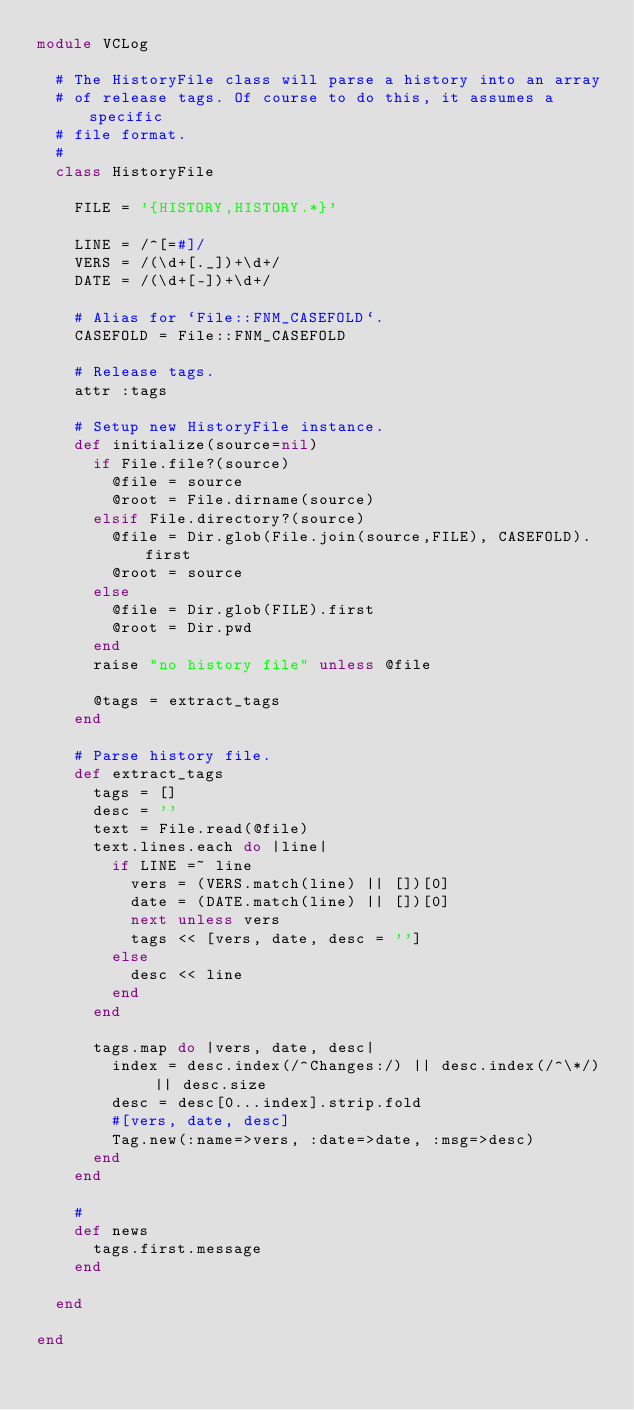Convert code to text. <code><loc_0><loc_0><loc_500><loc_500><_Ruby_>module VCLog

  # The HistoryFile class will parse a history into an array
  # of release tags. Of course to do this, it assumes a specific
  # file format.
  #
  class HistoryFile

    FILE = '{HISTORY,HISTORY.*}'

    LINE = /^[=#]/
    VERS = /(\d+[._])+\d+/
    DATE = /(\d+[-])+\d+/

    # Alias for `File::FNM_CASEFOLD`.
    CASEFOLD = File::FNM_CASEFOLD

    # Release tags.
    attr :tags

    # Setup new HistoryFile instance.
    def initialize(source=nil)
      if File.file?(source)
        @file = source
        @root = File.dirname(source)
      elsif File.directory?(source)
        @file = Dir.glob(File.join(source,FILE), CASEFOLD).first
        @root = source
      else
        @file = Dir.glob(FILE).first
        @root = Dir.pwd
      end
      raise "no history file" unless @file

      @tags = extract_tags
    end

    # Parse history file.
    def extract_tags
      tags = []
      desc = ''
      text = File.read(@file)
      text.lines.each do |line|
        if LINE =~ line
          vers = (VERS.match(line) || [])[0]
          date = (DATE.match(line) || [])[0]
          next unless vers
          tags << [vers, date, desc = '']
        else
          desc << line
        end
      end

      tags.map do |vers, date, desc|
        index = desc.index(/^Changes:/) || desc.index(/^\*/) || desc.size
        desc = desc[0...index].strip.fold
        #[vers, date, desc]
        Tag.new(:name=>vers, :date=>date, :msg=>desc)
      end
    end

    #
    def news
      tags.first.message
    end

  end

end
</code> 